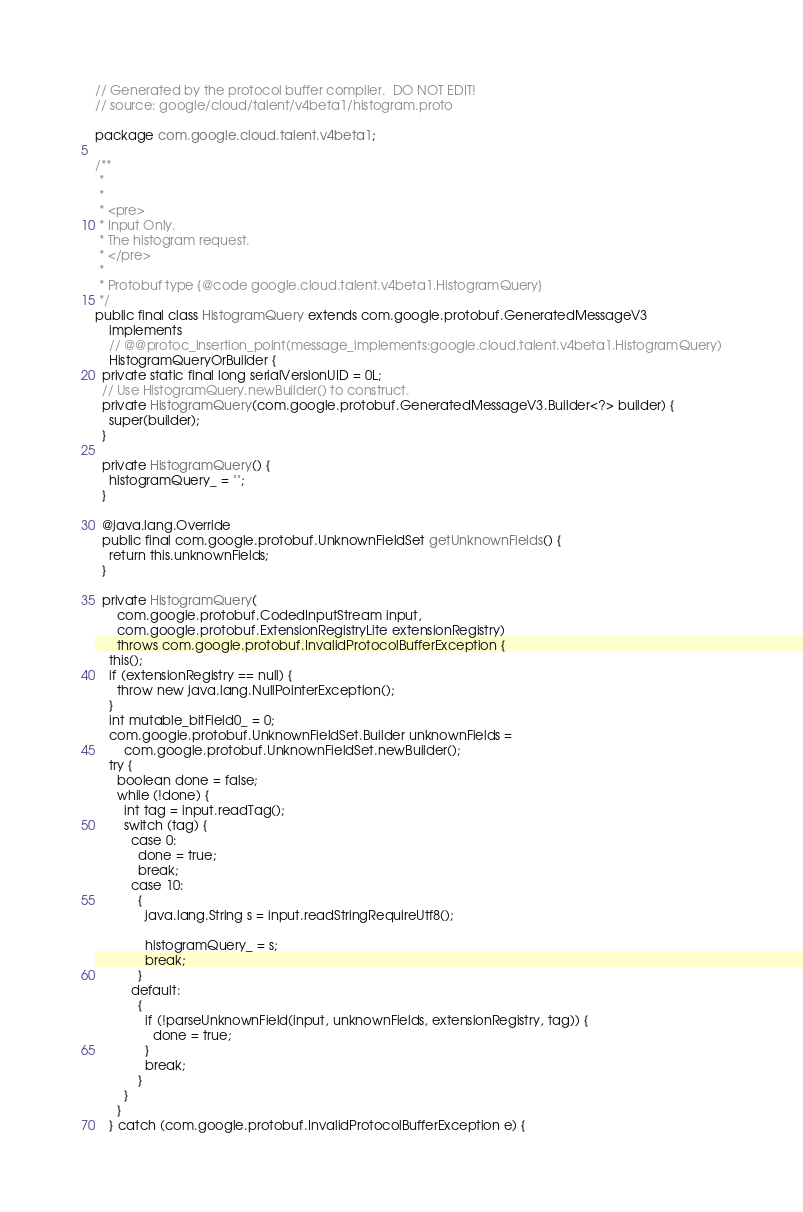<code> <loc_0><loc_0><loc_500><loc_500><_Java_>// Generated by the protocol buffer compiler.  DO NOT EDIT!
// source: google/cloud/talent/v4beta1/histogram.proto

package com.google.cloud.talent.v4beta1;

/**
 *
 *
 * <pre>
 * Input Only.
 * The histogram request.
 * </pre>
 *
 * Protobuf type {@code google.cloud.talent.v4beta1.HistogramQuery}
 */
public final class HistogramQuery extends com.google.protobuf.GeneratedMessageV3
    implements
    // @@protoc_insertion_point(message_implements:google.cloud.talent.v4beta1.HistogramQuery)
    HistogramQueryOrBuilder {
  private static final long serialVersionUID = 0L;
  // Use HistogramQuery.newBuilder() to construct.
  private HistogramQuery(com.google.protobuf.GeneratedMessageV3.Builder<?> builder) {
    super(builder);
  }

  private HistogramQuery() {
    histogramQuery_ = "";
  }

  @java.lang.Override
  public final com.google.protobuf.UnknownFieldSet getUnknownFields() {
    return this.unknownFields;
  }

  private HistogramQuery(
      com.google.protobuf.CodedInputStream input,
      com.google.protobuf.ExtensionRegistryLite extensionRegistry)
      throws com.google.protobuf.InvalidProtocolBufferException {
    this();
    if (extensionRegistry == null) {
      throw new java.lang.NullPointerException();
    }
    int mutable_bitField0_ = 0;
    com.google.protobuf.UnknownFieldSet.Builder unknownFields =
        com.google.protobuf.UnknownFieldSet.newBuilder();
    try {
      boolean done = false;
      while (!done) {
        int tag = input.readTag();
        switch (tag) {
          case 0:
            done = true;
            break;
          case 10:
            {
              java.lang.String s = input.readStringRequireUtf8();

              histogramQuery_ = s;
              break;
            }
          default:
            {
              if (!parseUnknownField(input, unknownFields, extensionRegistry, tag)) {
                done = true;
              }
              break;
            }
        }
      }
    } catch (com.google.protobuf.InvalidProtocolBufferException e) {</code> 